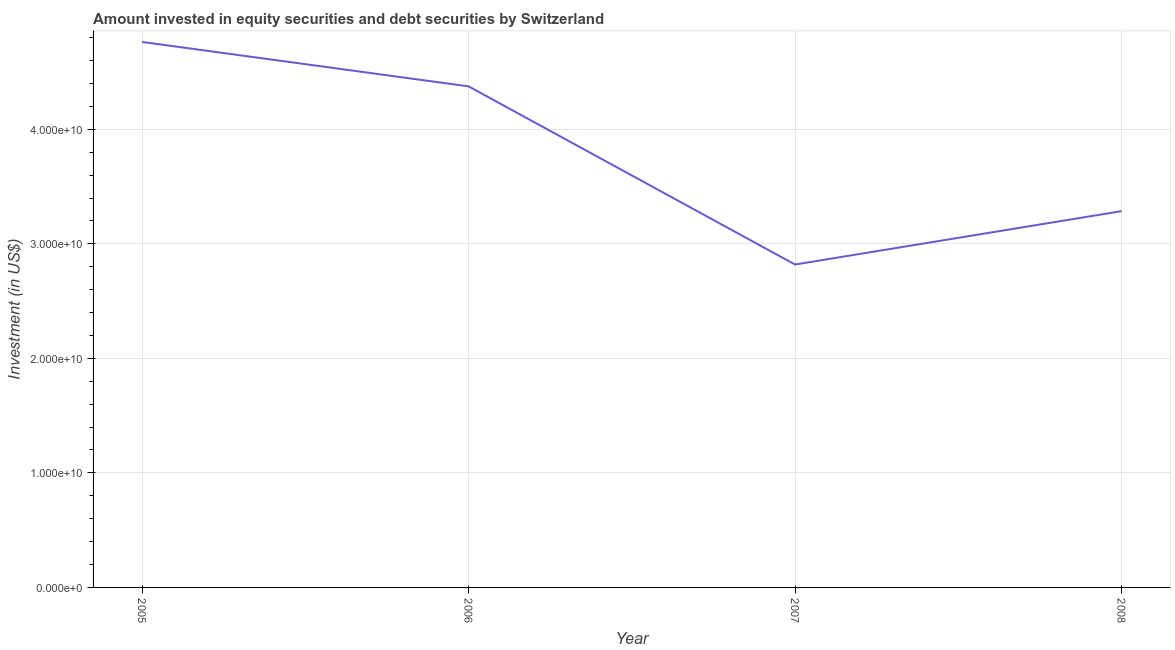What is the portfolio investment in 2007?
Ensure brevity in your answer.  2.82e+1. Across all years, what is the maximum portfolio investment?
Ensure brevity in your answer.  4.76e+1. Across all years, what is the minimum portfolio investment?
Provide a short and direct response. 2.82e+1. In which year was the portfolio investment minimum?
Offer a terse response. 2007. What is the sum of the portfolio investment?
Give a very brief answer. 1.52e+11. What is the difference between the portfolio investment in 2005 and 2007?
Provide a short and direct response. 1.94e+1. What is the average portfolio investment per year?
Ensure brevity in your answer.  3.81e+1. What is the median portfolio investment?
Offer a very short reply. 3.83e+1. In how many years, is the portfolio investment greater than 42000000000 US$?
Make the answer very short. 2. What is the ratio of the portfolio investment in 2007 to that in 2008?
Your response must be concise. 0.86. Is the portfolio investment in 2005 less than that in 2008?
Offer a terse response. No. What is the difference between the highest and the second highest portfolio investment?
Offer a very short reply. 3.88e+09. What is the difference between the highest and the lowest portfolio investment?
Offer a terse response. 1.94e+1. In how many years, is the portfolio investment greater than the average portfolio investment taken over all years?
Provide a short and direct response. 2. Are the values on the major ticks of Y-axis written in scientific E-notation?
Keep it short and to the point. Yes. Does the graph contain any zero values?
Keep it short and to the point. No. What is the title of the graph?
Give a very brief answer. Amount invested in equity securities and debt securities by Switzerland. What is the label or title of the X-axis?
Keep it short and to the point. Year. What is the label or title of the Y-axis?
Give a very brief answer. Investment (in US$). What is the Investment (in US$) in 2005?
Keep it short and to the point. 4.76e+1. What is the Investment (in US$) in 2006?
Make the answer very short. 4.37e+1. What is the Investment (in US$) of 2007?
Offer a terse response. 2.82e+1. What is the Investment (in US$) in 2008?
Provide a succinct answer. 3.29e+1. What is the difference between the Investment (in US$) in 2005 and 2006?
Offer a terse response. 3.88e+09. What is the difference between the Investment (in US$) in 2005 and 2007?
Keep it short and to the point. 1.94e+1. What is the difference between the Investment (in US$) in 2005 and 2008?
Provide a short and direct response. 1.48e+1. What is the difference between the Investment (in US$) in 2006 and 2007?
Provide a short and direct response. 1.56e+1. What is the difference between the Investment (in US$) in 2006 and 2008?
Keep it short and to the point. 1.09e+1. What is the difference between the Investment (in US$) in 2007 and 2008?
Provide a short and direct response. -4.66e+09. What is the ratio of the Investment (in US$) in 2005 to that in 2006?
Provide a short and direct response. 1.09. What is the ratio of the Investment (in US$) in 2005 to that in 2007?
Give a very brief answer. 1.69. What is the ratio of the Investment (in US$) in 2005 to that in 2008?
Make the answer very short. 1.45. What is the ratio of the Investment (in US$) in 2006 to that in 2007?
Your answer should be very brief. 1.55. What is the ratio of the Investment (in US$) in 2006 to that in 2008?
Keep it short and to the point. 1.33. What is the ratio of the Investment (in US$) in 2007 to that in 2008?
Give a very brief answer. 0.86. 